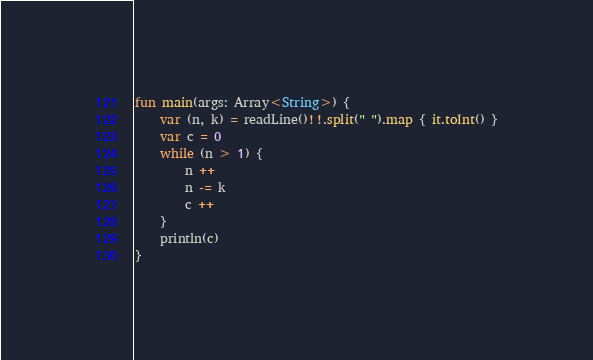<code> <loc_0><loc_0><loc_500><loc_500><_Kotlin_>fun main(args: Array<String>) {
    var (n, k) = readLine()!!.split(" ").map { it.toInt() }
    var c = 0
    while (n > 1) {
        n ++
        n -= k
        c ++ 
    }
    println(c)
}
</code> 